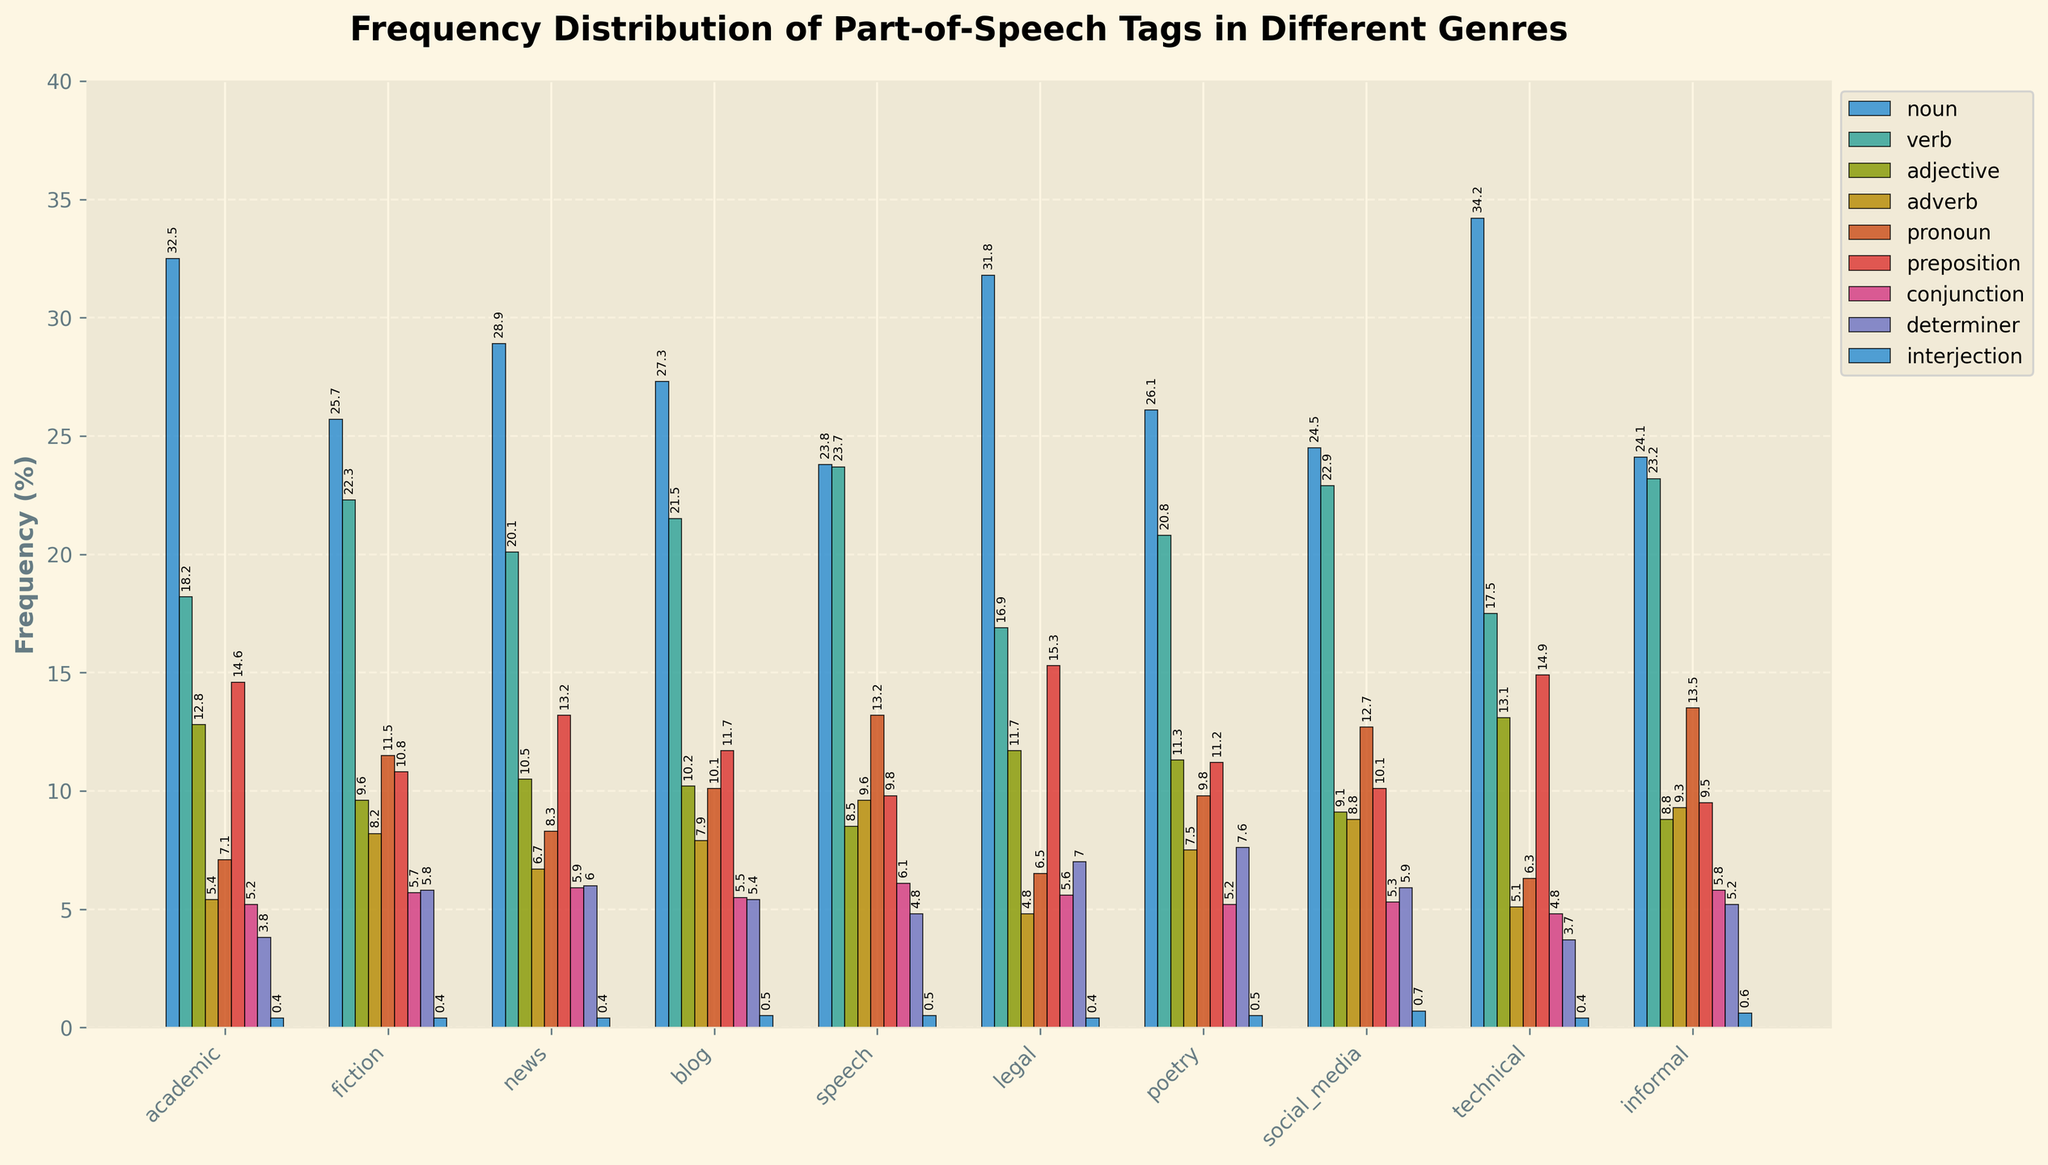What's the most frequent part-of-speech tag in the academic genre? The bar for the noun tag in the academic genre is the tallest compared to the other tags, indicating that nouns have the highest frequency.
Answer: Noun Which genre shows the highest frequency for verbs? Among all genres represented by the bars for verbs, the speech genre has the highest bar, indicating that it has the highest frequency of verbs.
Answer: Speech What's the difference in the frequency of adjectives between the academic and fiction genres? The frequency of adjectives in the academic genre is 12.8%, while in the fiction genre, it is 9.6%. The difference is calculated as 12.8 - 9.6.
Answer: 3.2% Which genre has the lowest frequency of pronouns and what is that frequency? The bar for pronouns in the technical genre is the shortest compared to other genres, indicating that it has the lowest frequency of pronouns. The label on the bar indicates this frequency is 6.3%.
Answer: Technical, 6.3% In which genre is the frequency of adverbs more than twice the frequency of interjections? By scanning the frequencies of adverbs and checking if they are more than double the corresponding interjection frequencies, the speech genre stands out with its adverb frequency (9.6%) being more than double its interjection frequency (0.5%).
Answer: Speech What genre has the most balanced distribution of part-of-speech tags, roughly taking into account similar heights of the bars? By visually comparing the heights of the bars for each genre, the informal genre appears to have bars of similar height across different tags, indicating a balanced distribution.
Answer: Informal Is there a genre where the frequency of determiners is closest to the frequency of adjectives? In the news genre, the frequencies of determiners (6.0%) and adjectives (10.5%) are relatively closest compared to other genres, though this is subjective and not precisely equal.
Answer: News If you sum the frequencies of nouns and prepositions in the legal genre, what do you get? The frequency of nouns in the legal genre is 31.8%, and prepositions is 15.3%. Summing these up: 31.8 + 15.3.
Answer: 47.1% Which genre shows a higher frequency of conjunctions, fiction or technical? The bar for conjunctions in the fiction genre is higher than that in the technical genre. Fiction has 5.7% while technical has 4.8%.
Answer: Fiction Comparing the blog and social_media genres, which has a higher frequency of prepositions and by how much? The frequency of prepositions in the blog genre is 11.7%, and in the social_media genre, it is 10.1%. The difference is 11.7 - 10.1.
Answer: Blog, 1.6% 